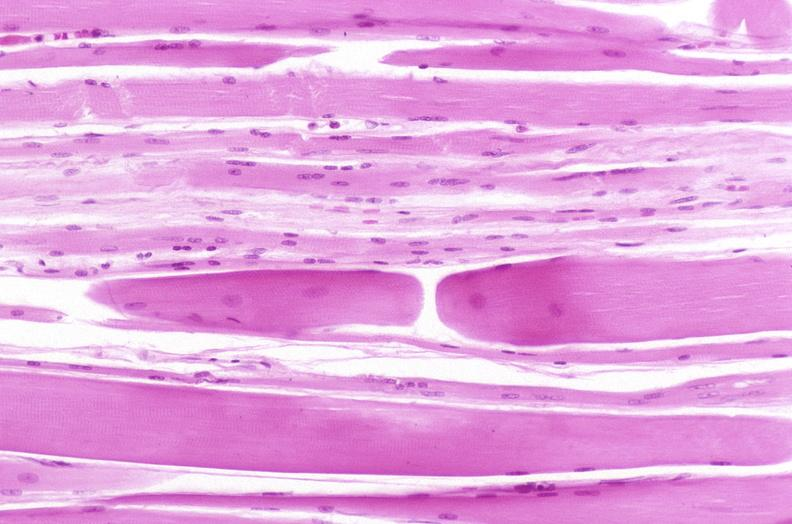what is present?
Answer the question using a single word or phrase. Musculoskeletal 